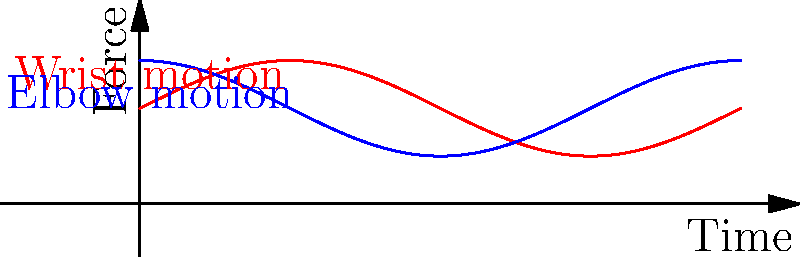The graph shows the force exerted by a server's wrist (red) and elbow (blue) joints during a repetitive plating motion. If the server performs this motion 100 times per hour for a 6-hour shift, what is the total work done by the wrist joint, assuming the average displacement for each motion is 0.3 meters? Let's break this down step-by-step:

1) First, we need to calculate the average force exerted by the wrist joint. From the graph, we can see that the force oscillates between 0.5 and 1.5 units. The average force is therefore:

   $F_{avg} = \frac{0.5 + 1.5}{2} = 1$ unit

2) We're told that the average displacement for each motion is 0.3 meters.

3) Work is calculated using the formula: $W = F \times d$
   Where W is work, F is force, and d is displacement.

4) For a single motion:
   $W_{single} = 1 \times 0.3 = 0.3$ joules

5) The server performs this motion 100 times per hour for 6 hours. So the total number of motions is:
   $N_{total} = 100 \times 6 = 600$ motions

6) Therefore, the total work done is:
   $W_{total} = W_{single} \times N_{total} = 0.3 \times 600 = 180$ joules
Answer: 180 joules 